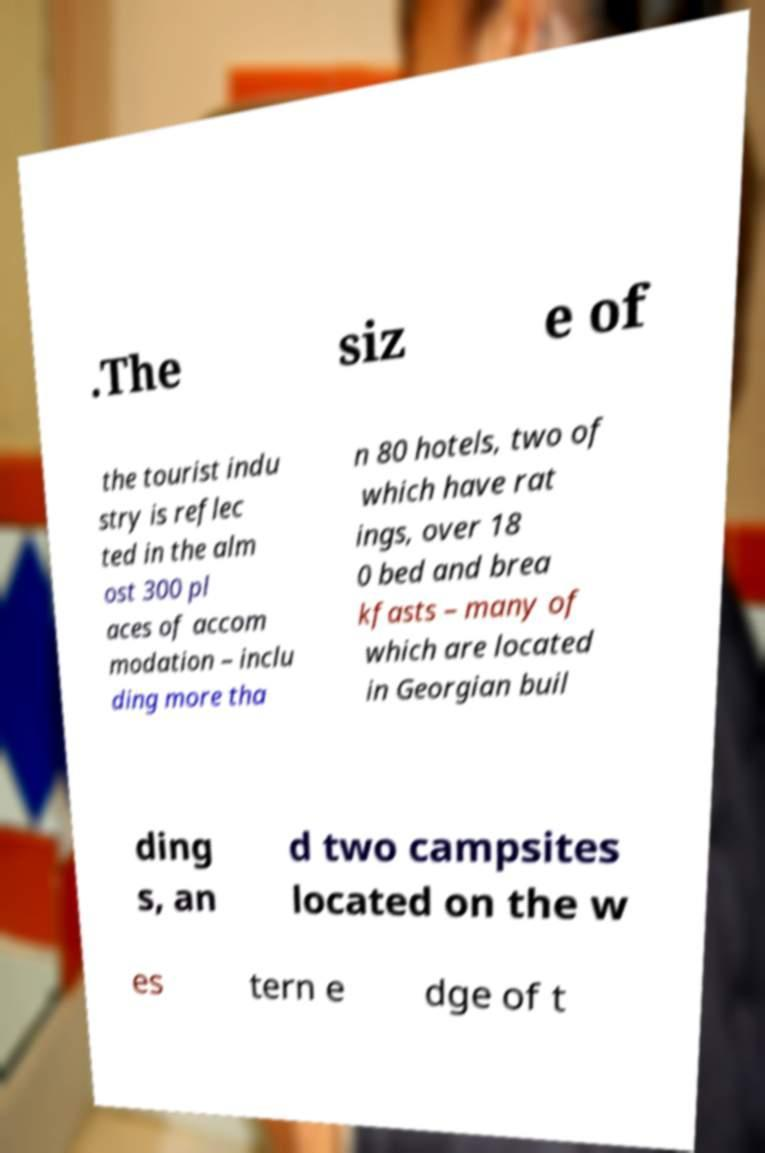Please identify and transcribe the text found in this image. .The siz e of the tourist indu stry is reflec ted in the alm ost 300 pl aces of accom modation – inclu ding more tha n 80 hotels, two of which have rat ings, over 18 0 bed and brea kfasts – many of which are located in Georgian buil ding s, an d two campsites located on the w es tern e dge of t 